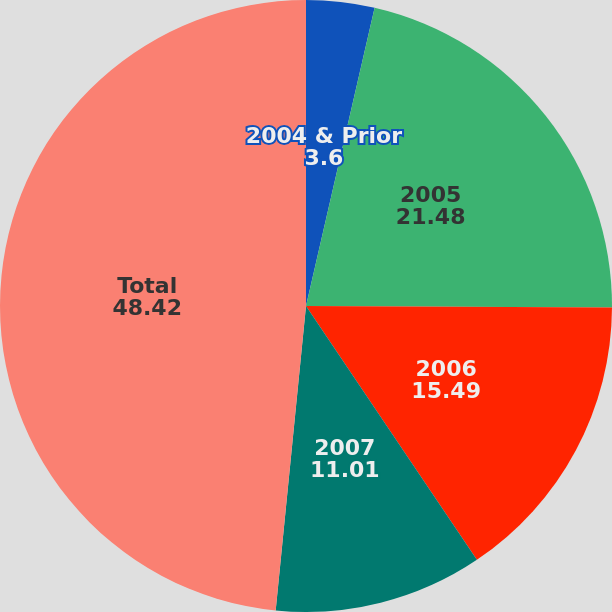<chart> <loc_0><loc_0><loc_500><loc_500><pie_chart><fcel>2004 & Prior<fcel>2005<fcel>2006<fcel>2007<fcel>Total<nl><fcel>3.6%<fcel>21.48%<fcel>15.49%<fcel>11.01%<fcel>48.42%<nl></chart> 